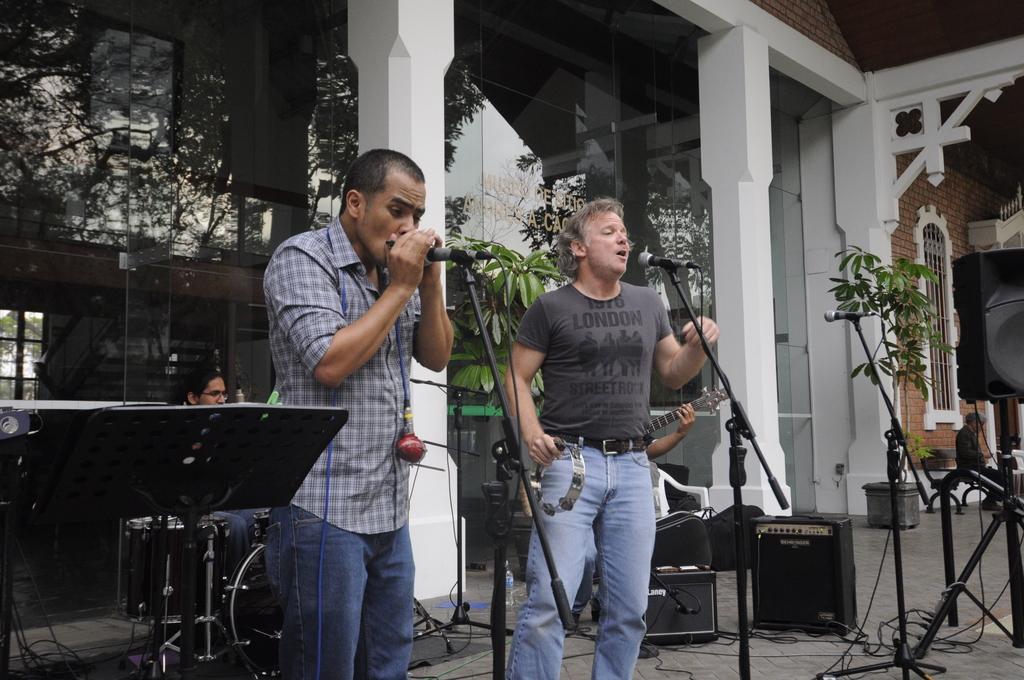Can you describe this image briefly? In this image I can see two people standing in front of the mic and singing. In the back there are two people sitting. I can also see some plants in the image. At the back there is a building with glass. 